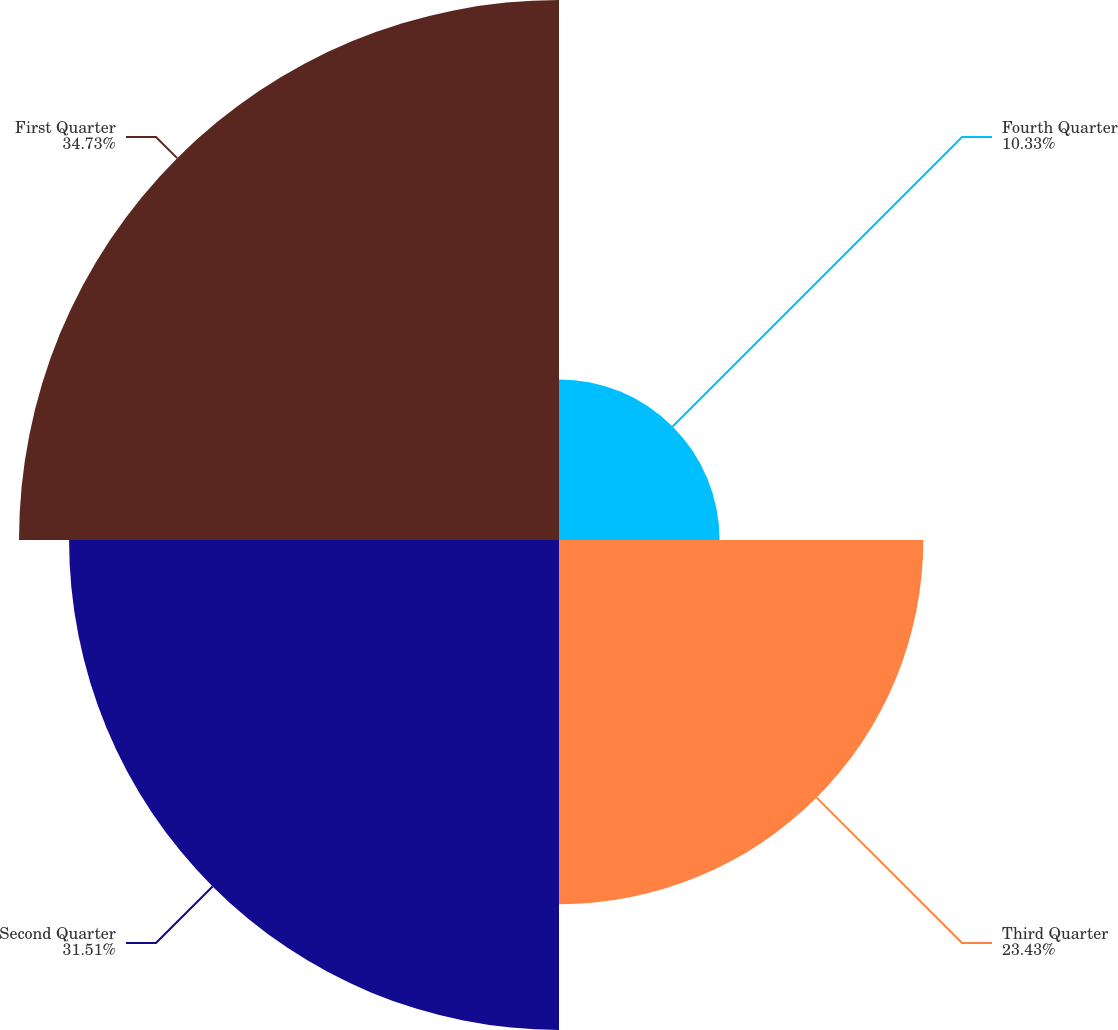Convert chart. <chart><loc_0><loc_0><loc_500><loc_500><pie_chart><fcel>Fourth Quarter<fcel>Third Quarter<fcel>Second Quarter<fcel>First Quarter<nl><fcel>10.33%<fcel>23.43%<fcel>31.51%<fcel>34.73%<nl></chart> 